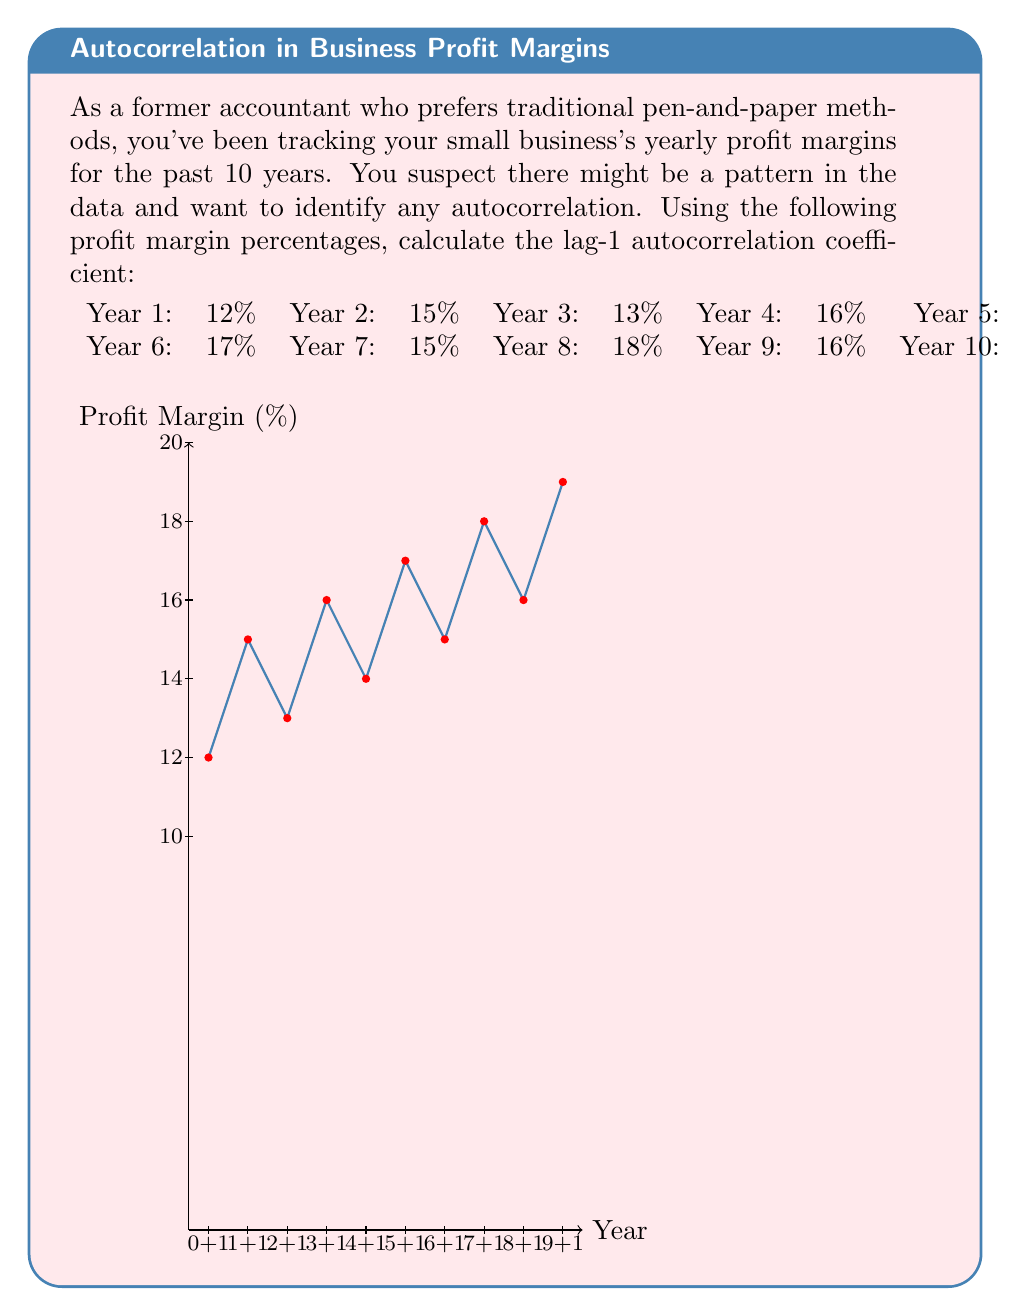Can you solve this math problem? To calculate the lag-1 autocorrelation coefficient, we'll follow these steps:

1) Calculate the mean ($\bar{x}$) of the profit margins:
   $$\bar{x} = \frac{12 + 15 + 13 + 16 + 14 + 17 + 15 + 18 + 16 + 19}{10} = 15.5$$

2) Calculate the numerator of the autocorrelation formula:
   $$\sum_{t=1}^{n-1} (x_t - \bar{x})(x_{t+1} - \bar{x})$$
   
   $(12 - 15.5)(15 - 15.5) + (15 - 15.5)(13 - 15.5) + ... + (16 - 15.5)(19 - 15.5)$
   $= (-3.5)(-0.5) + (-0.5)(-2.5) + ... + (0.5)(3.5)$
   $= 1.75 + 1.25 + ... + 1.75 = 8.5$

3) Calculate the denominator of the autocorrelation formula:
   $$\sum_{t=1}^{n} (x_t - \bar{x})^2$$
   
   $(12 - 15.5)^2 + (15 - 15.5)^2 + ... + (19 - 15.5)^2$
   $= (-3.5)^2 + (-0.5)^2 + ... + (3.5)^2$
   $= 12.25 + 0.25 + ... + 12.25 = 46$

4) The lag-1 autocorrelation coefficient is:
   $$r_1 = \frac{8.5}{46} \approx 0.1848$$
Answer: $0.1848$ 